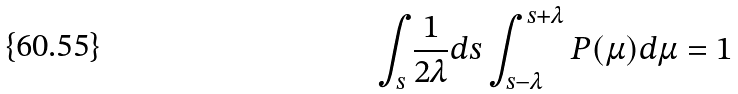Convert formula to latex. <formula><loc_0><loc_0><loc_500><loc_500>\int _ { s } \frac { 1 } { 2 \lambda } d s \int _ { s - \lambda } ^ { s + \lambda } P ( \mu ) d \mu = 1</formula> 